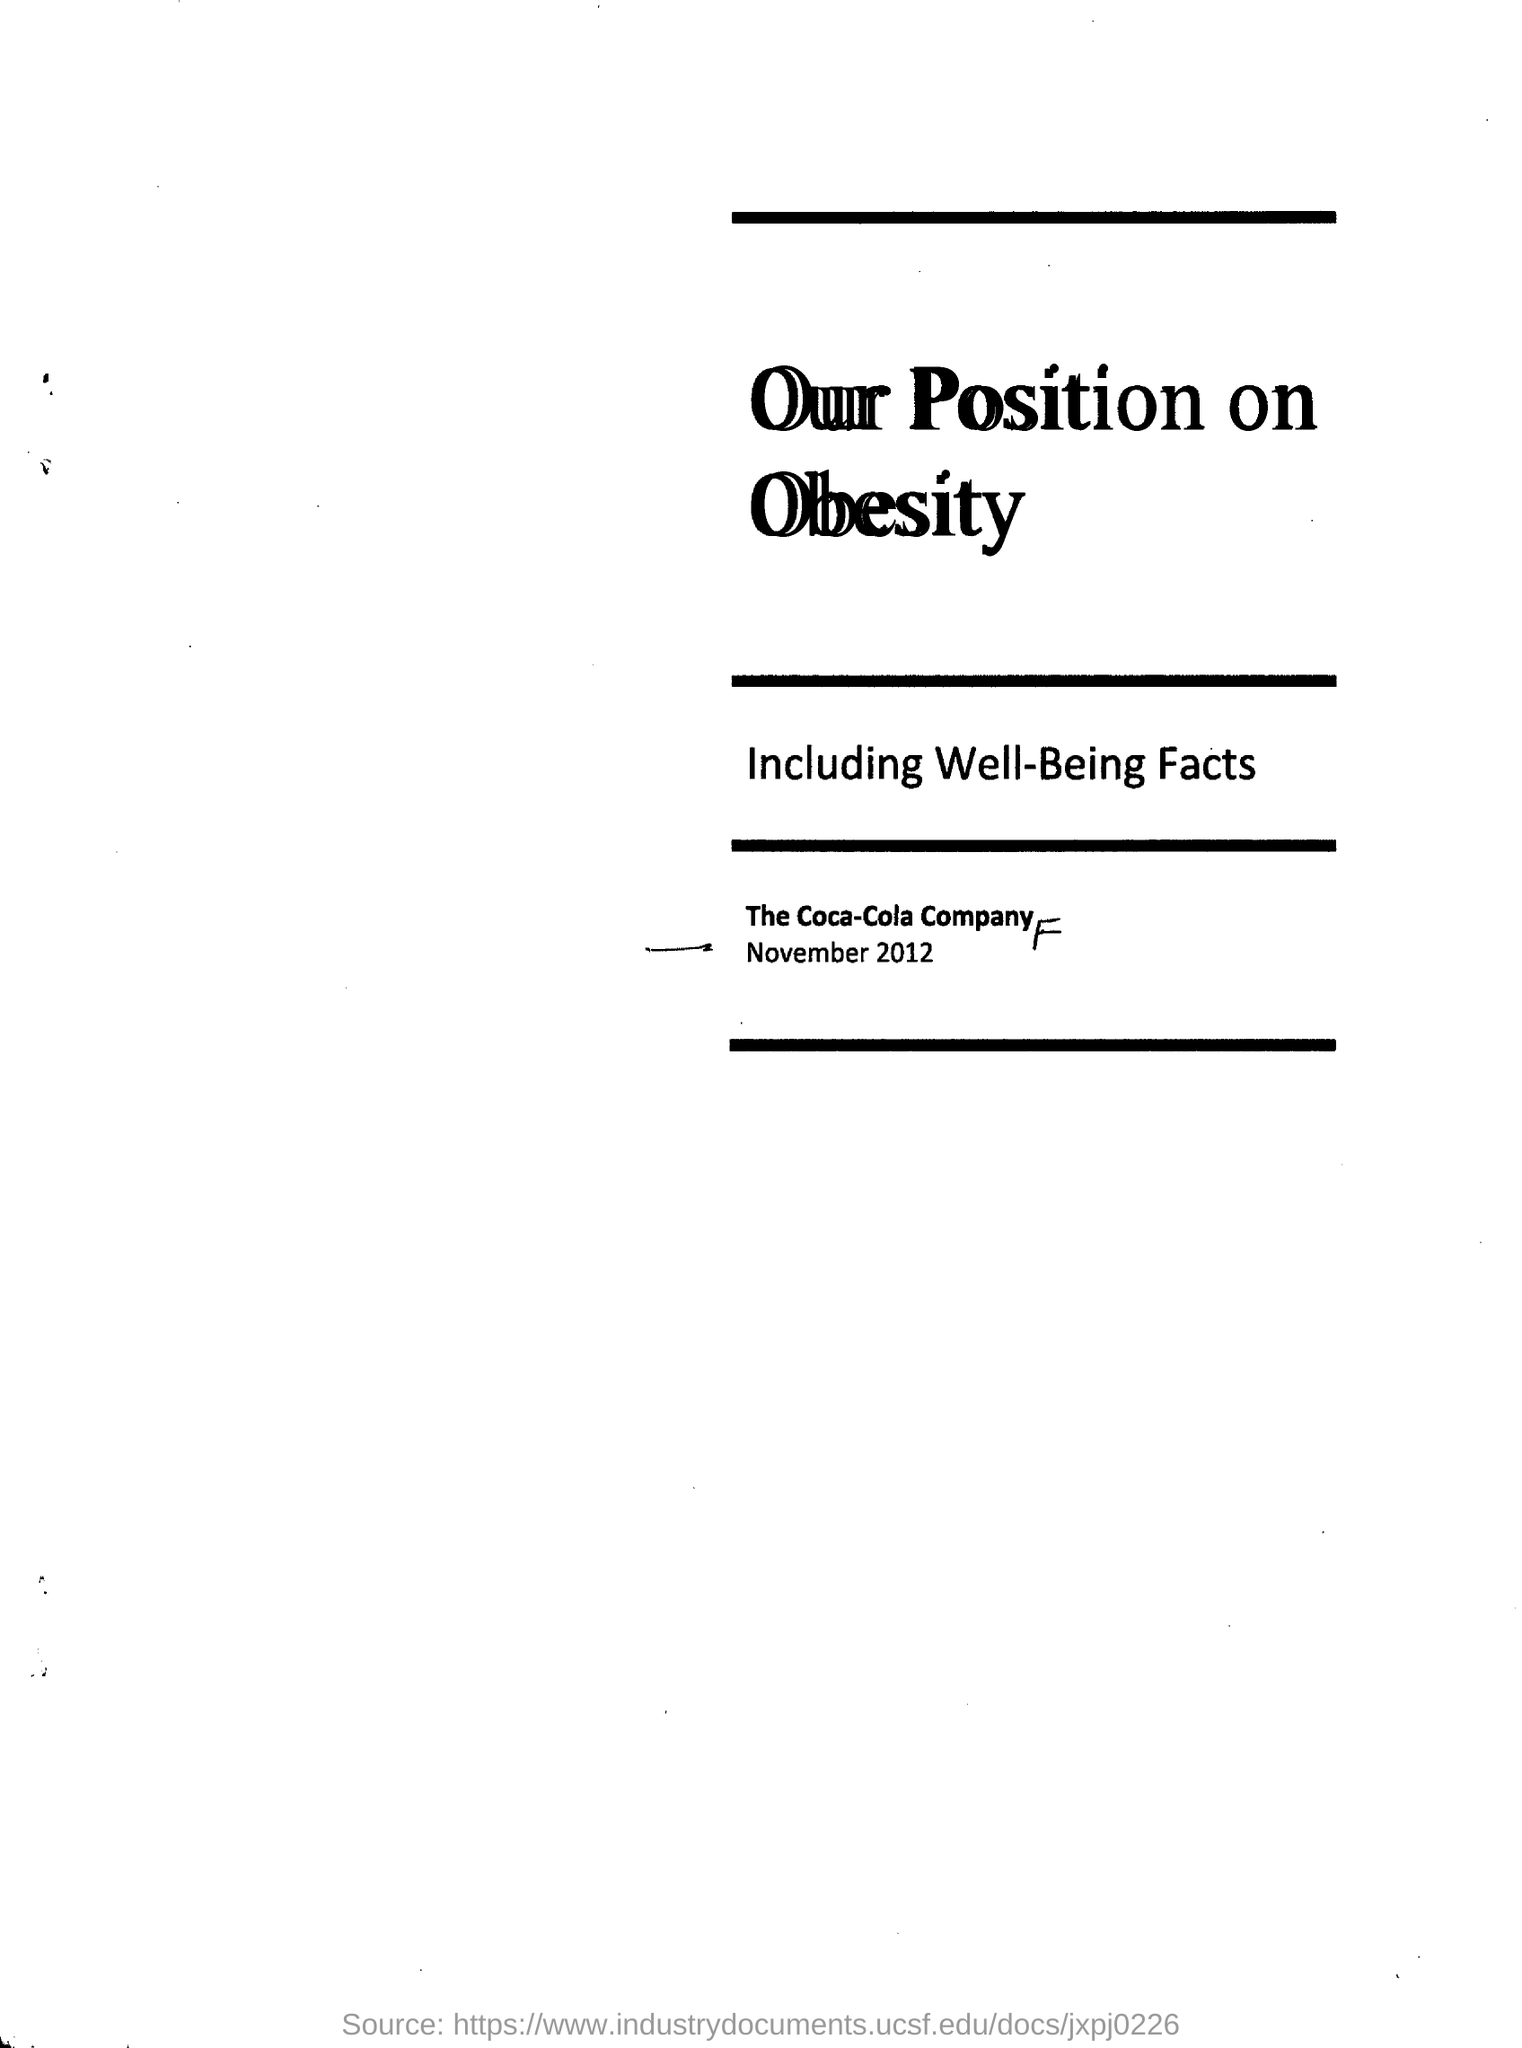Draw attention to some important aspects in this diagram. The document mentions The Coca-Cola Company. 